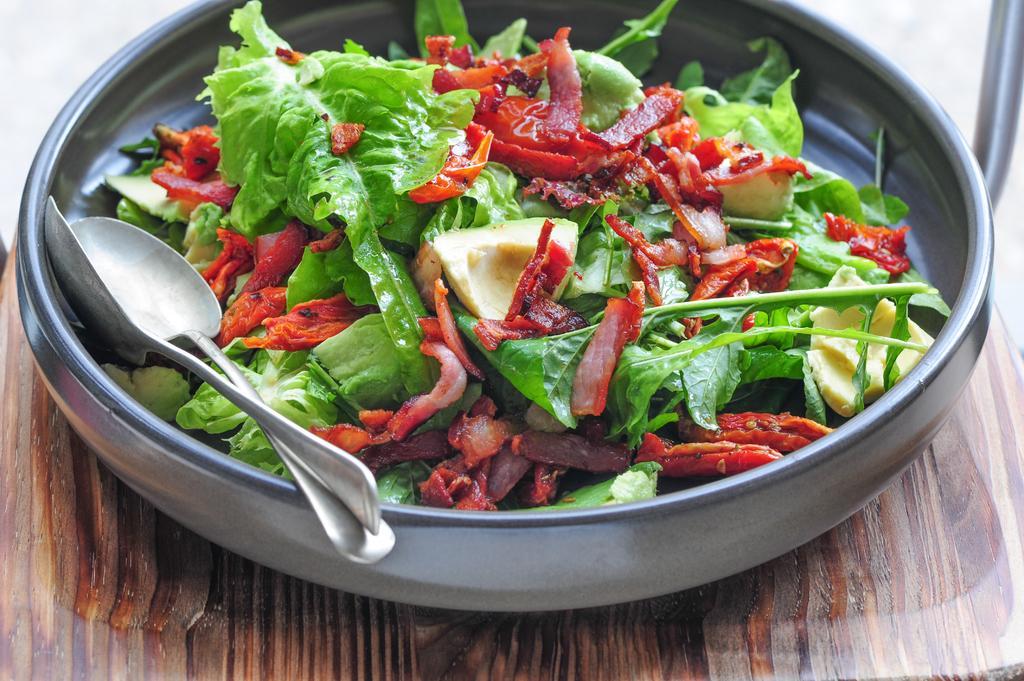Describe this image in one or two sentences. In the picture we can see a wooden plank on it we can see a dish with some leafy vegetables and two spoons in it. 